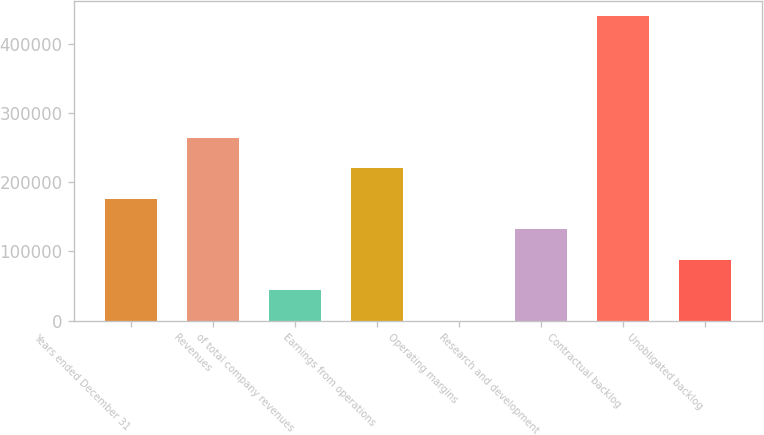<chart> <loc_0><loc_0><loc_500><loc_500><bar_chart><fcel>Years ended December 31<fcel>Revenues<fcel>of total company revenues<fcel>Earnings from operations<fcel>Operating margins<fcel>Research and development<fcel>Contractual backlog<fcel>Unobligated backlog<nl><fcel>176054<fcel>264075<fcel>44021.4<fcel>220064<fcel>10.7<fcel>132043<fcel>440118<fcel>88032.2<nl></chart> 